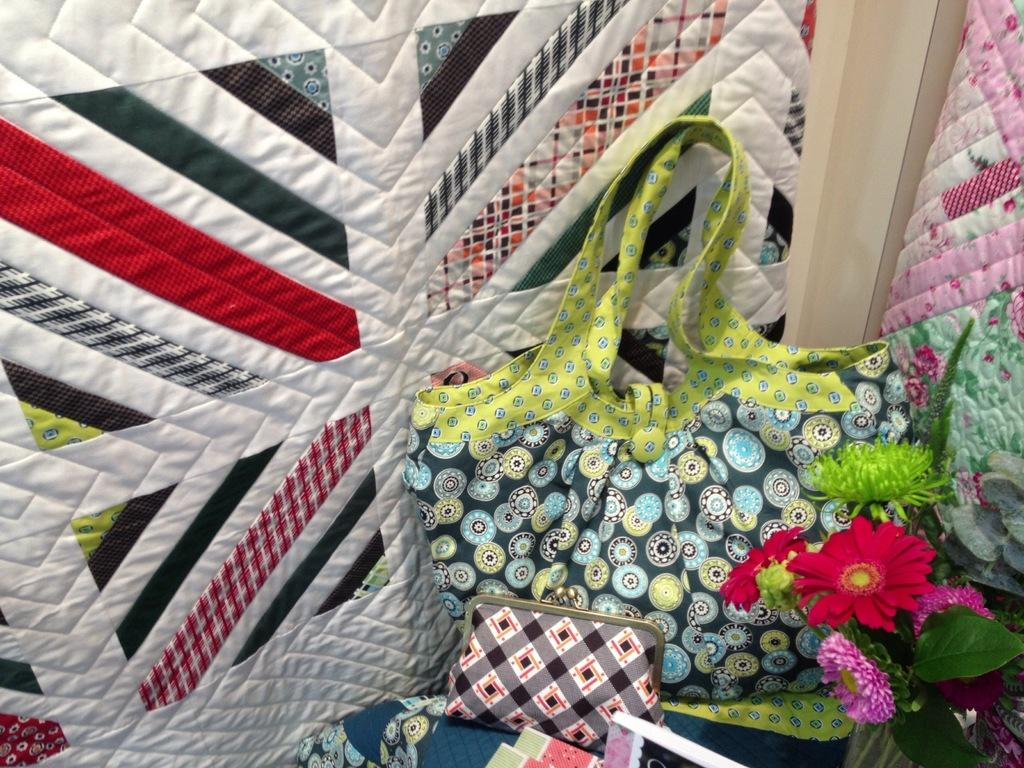What items can be seen in the image that are typically used for carrying or storing things? There are bags in the image. What type of items are visible in the image that people wear? There are clothes in the image. What items can be seen in the image that are used for reading or learning? There are books in the image. What type of natural elements can be seen in the image? There are leaves and flowers in the image. Can you hear the voice of the expert in the image? There is no voice or expert present in the image; it only contains bags, clothes, books, leaves, and flowers. Is there a trail visible in the image? There is no trail present in the image. 